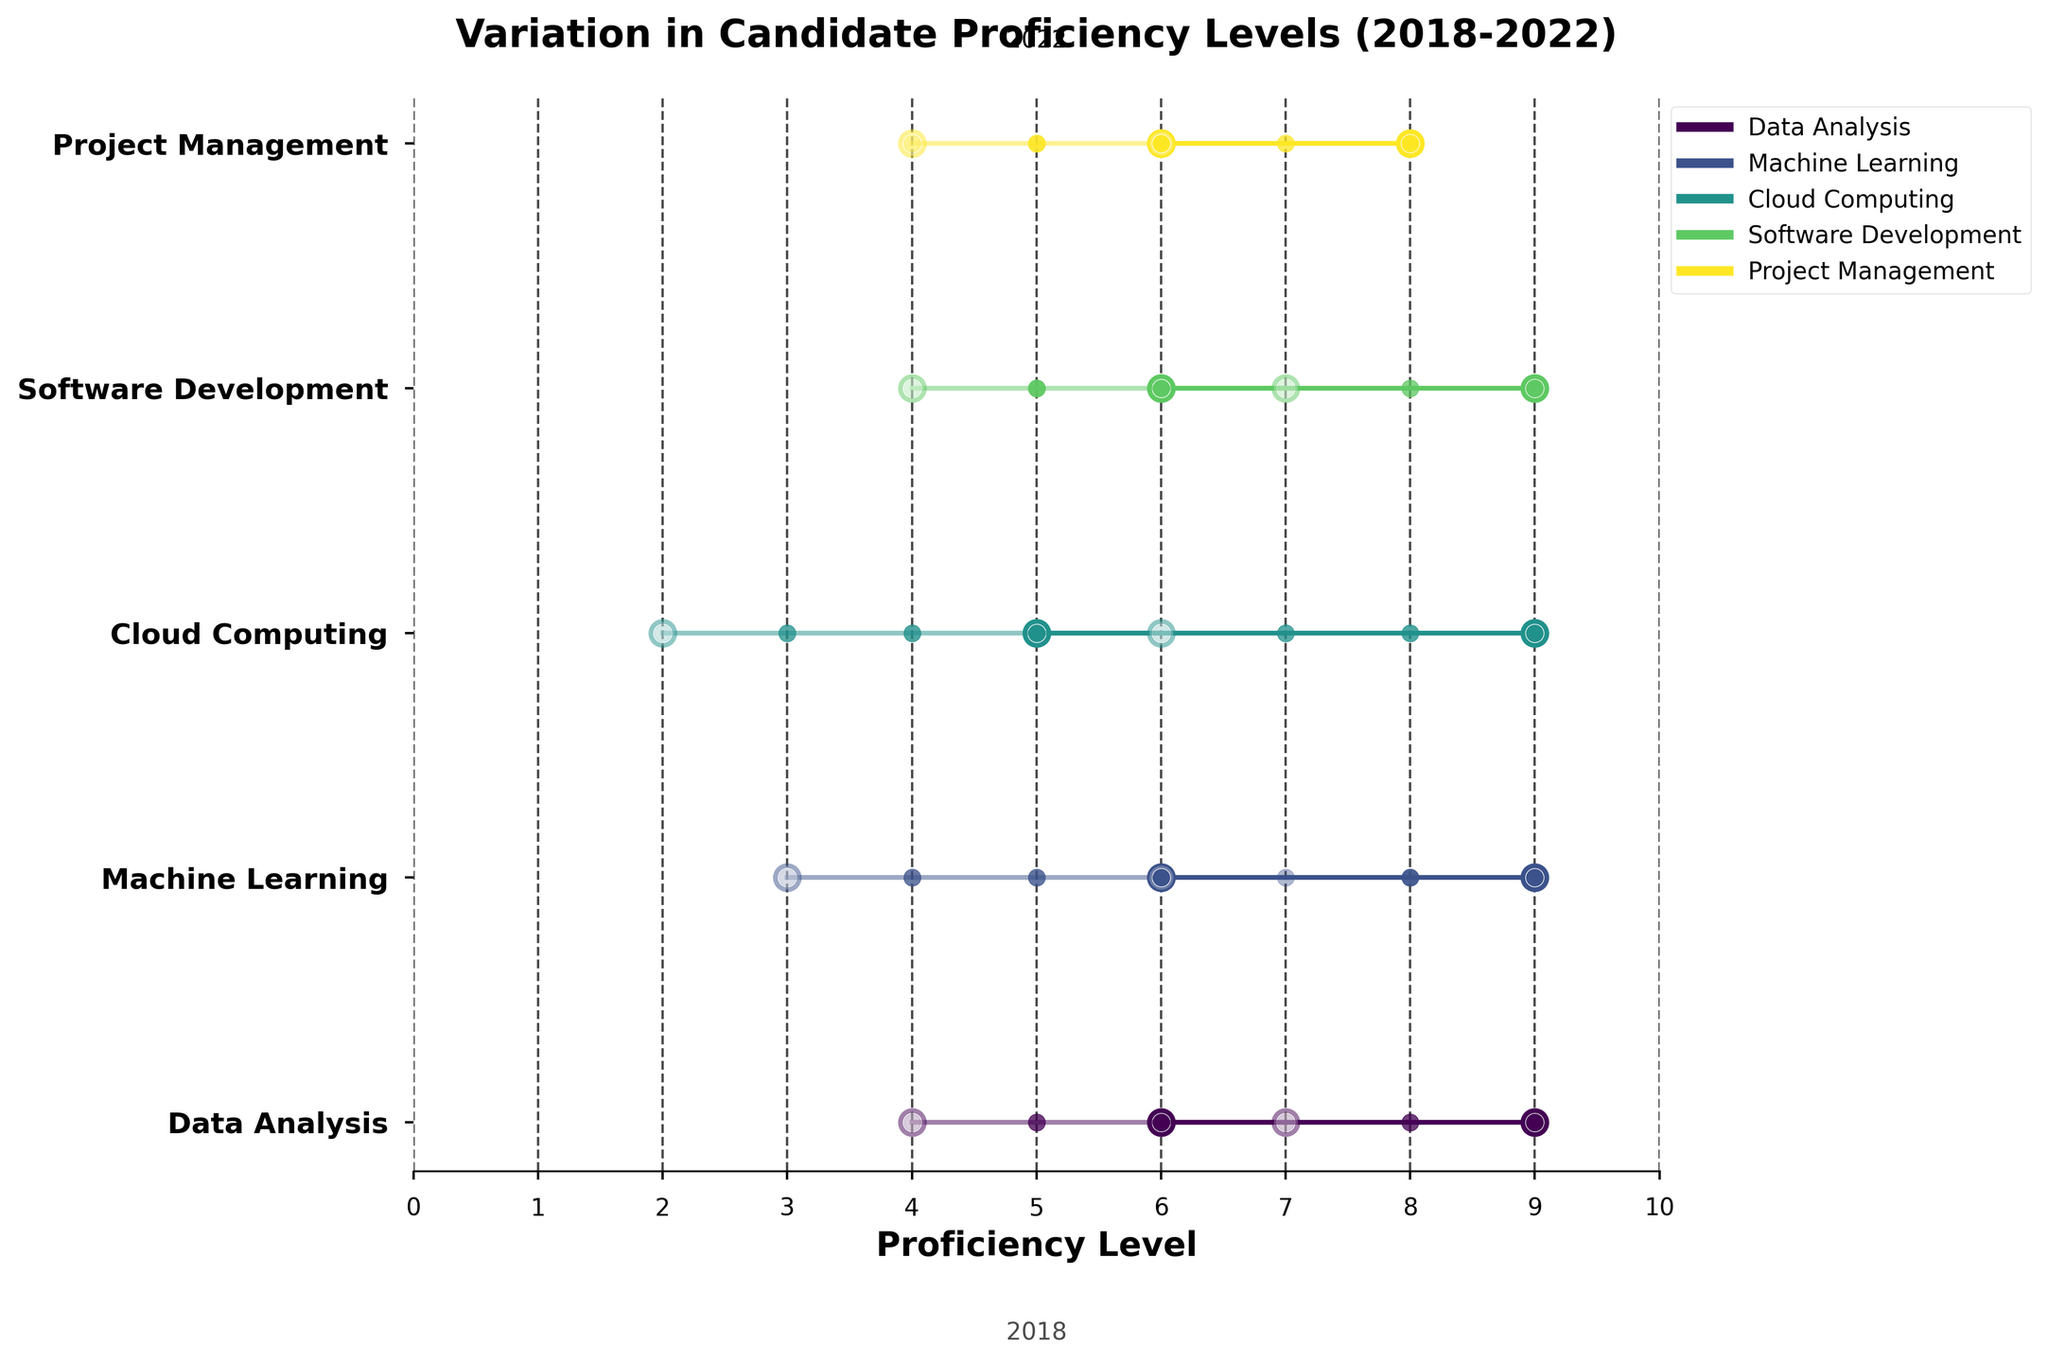Which skill showed the highest increase in maximum proficiency level from 2018 to 2022? Look at the change in maximum proficiency levels for each skill from 2018 to 2022. Calculate the increase and identify the skill with the greatest increase. Machine Learning and Data Analysis both increase by 3, but Cloud Computing shows an increase of 3, which is the highest.
Answer: Cloud Computing What is the minimum proficiency level for Project Management in 2021? Identify the y-position for Project Management and trace it to the year 2021. Look at the minimum proficiency point's value on the x-axis.
Answer: 5 How does the proficiency range for Data Analysis in 2019 compare to that in 2022? Find the minimum and maximum proficiency levels for Data Analysis in both 2019 and 2022. Compare the ranges by subtracting the minimum from the maximum for each year. For 2019, the range is 8 - 5 = 3. For 2022, the range is 9 - 6 = 3.
Answer: Same Which skill showed the most stability (least variation) in minimum proficiency levels over the years? Calculate the variance or range for the minimum proficiency levels for each skill over the years. Identify the skill with the smallest variance or range. Project Management has the minimum values of 4, 4, 5, 5, 6 with a difference of 2.
Answer: Project Management What is the average minimum proficiency level for Cloud Computing from 2018 to 2022? Sum the minimum proficiency levels for Cloud Computing from 2018 to 2022 and divide by the number of years. (2 + 3 + 3 + 4 + 5)/5 = 17/5 = 3.4
Answer: 3.4 Which year had the highest overall maximum proficiency levels across all skills? Sum the maximum proficiency levels for each year and compare them. The sum for each year is: 2018 = 32, 2019 = 37, 2020 = 38, 2021 = 43, 2022 = 49. The highest is for 2022.
Answer: 2022 How did the minimum proficiency level for Software Development change from 2018 to 2022? Identify the minimum proficiency levels for Software Development in 2018 and 2022. Calculate the change by subtracting the 2018 value from the 2022 value. The change is 6 - 4 = 2.
Answer: Increased by 2 